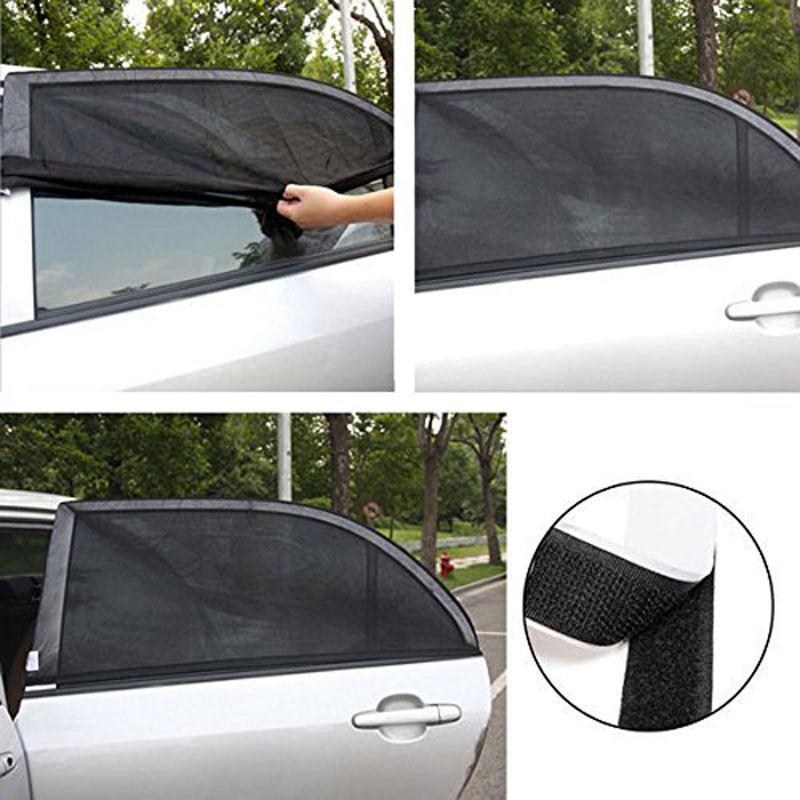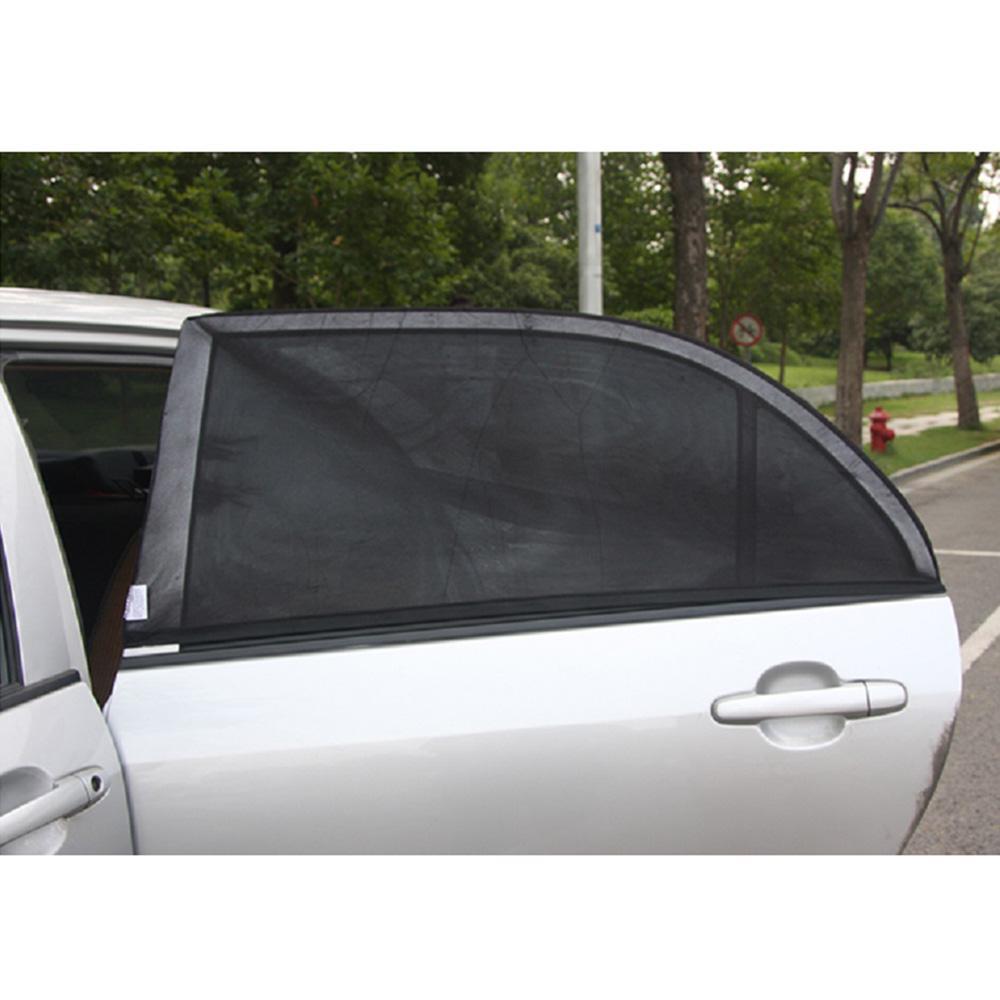The first image is the image on the left, the second image is the image on the right. Evaluate the accuracy of this statement regarding the images: "In at last one image, a person's hand is shown extending a car window shade.". Is it true? Answer yes or no. Yes. 